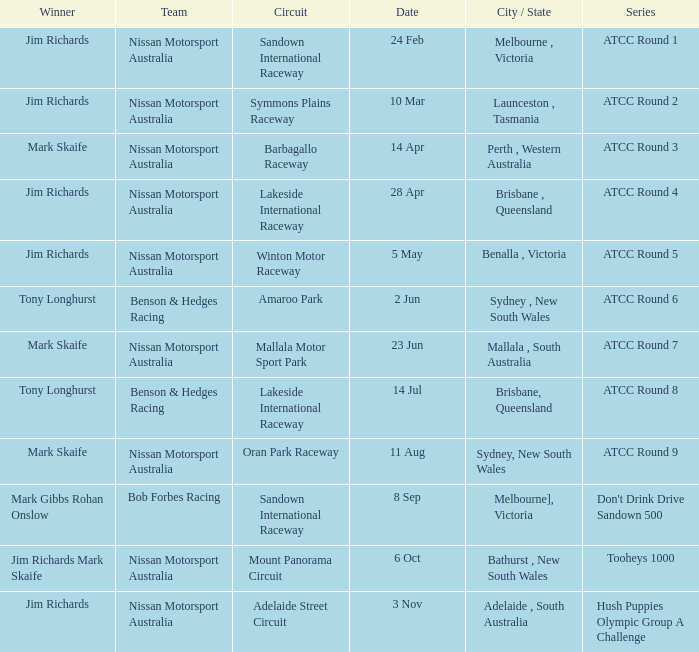Who is the Winner of the Nissan Motorsport Australia Team at the Oran Park Raceway? Mark Skaife. 